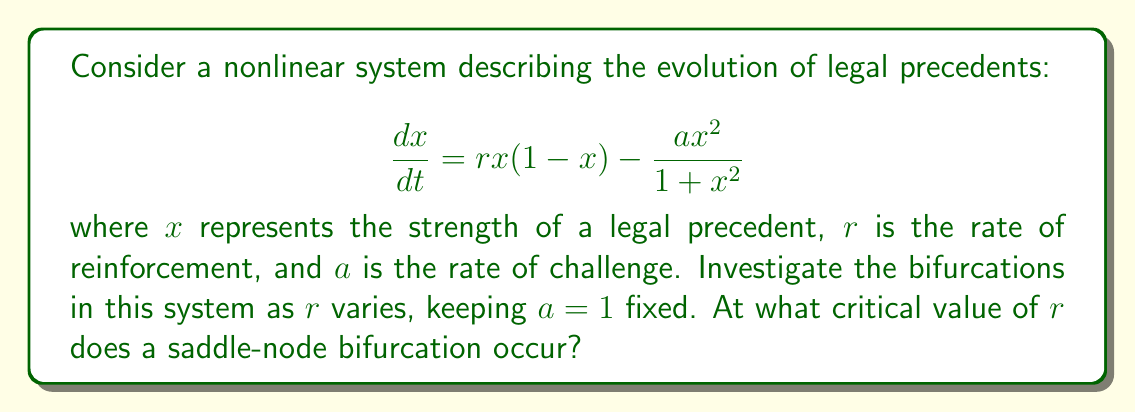Can you solve this math problem? To investigate the bifurcations, we follow these steps:

1) First, find the equilibrium points by setting $\frac{dx}{dt} = 0$:

   $$rx(1-x) - \frac{x^2}{1+x^2} = 0$$

2) This can be rearranged to:

   $$rx(1-x)(1+x^2) = x^2$$
   $$rx + rx^3 - rx^2 - rx^4 = x^2$$
   $$rx^4 + (r-1)x^2 - rx = 0$$

3) This is a fourth-degree polynomial equation. A saddle-node bifurcation occurs when this equation has a double root, which happens when the discriminant of the equation is zero.

4) To simplify, let $y = x^2$. Then our equation becomes:

   $$ry^2 + (r-1)y - rx = 0$$

5) For a quadratic equation $ay^2 + by + c = 0$, the discriminant is $b^2 - 4ac$. Here:

   $a = r$
   $b = r-1$
   $c = -rx$

6) Setting the discriminant to zero:

   $$(r-1)^2 - 4r(-rx) = 0$$
   $$(r-1)^2 + 4r^2x = 0$$

7) At the bifurcation point, this should be true for some $x$. The left side is minimized when $x = \frac{1}{2}$ (you can verify this by differentiation). Substituting this:

   $$(r-1)^2 + r^2 = 0$$

8) Expanding:

   $$r^2 - 2r + 1 + r^2 = 0$$
   $$2r^2 - 2r + 1 = 0$$

9) Solving this quadratic equation:

   $$r = \frac{2 \pm \sqrt{4 - 8}}{4} = \frac{2 \pm \sqrt{-4}}{4}$$

10) The real solution is:

    $$r = \frac{1}{2}$$

This is the critical value of $r$ at which the saddle-node bifurcation occurs.
Answer: $r = \frac{1}{2}$ 